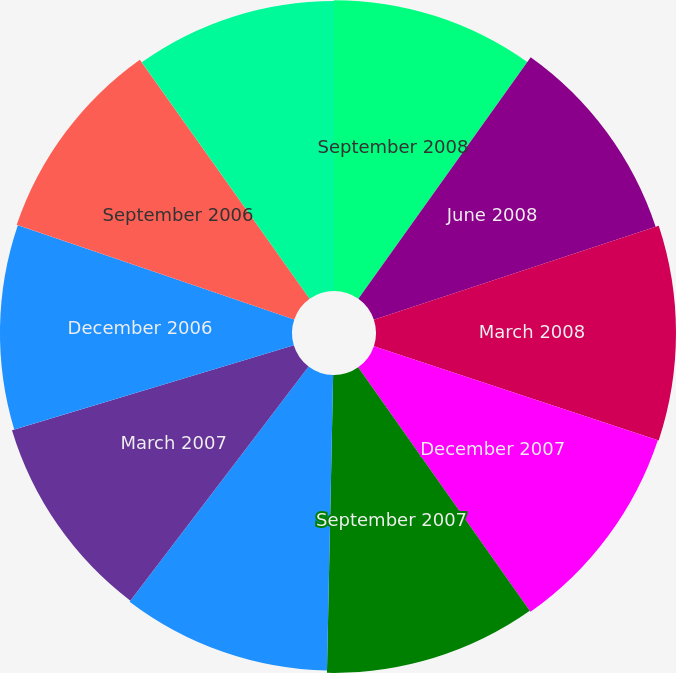Convert chart to OTSL. <chart><loc_0><loc_0><loc_500><loc_500><pie_chart><fcel>September 2008<fcel>June 2008<fcel>March 2008<fcel>December 2007<fcel>September 2007<fcel>June 2007<fcel>March 2007<fcel>December 2006<fcel>September 2006<fcel>June 2006<nl><fcel>9.86%<fcel>10.06%<fcel>10.17%<fcel>10.14%<fcel>10.1%<fcel>10.02%<fcel>9.98%<fcel>9.9%<fcel>9.94%<fcel>9.83%<nl></chart> 